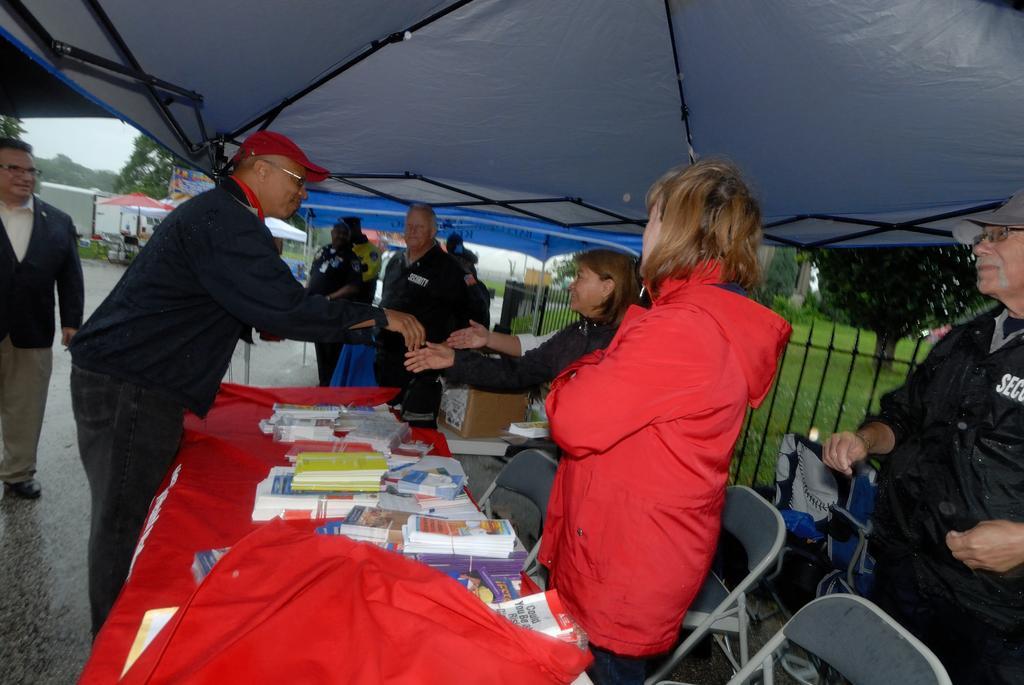Please provide a concise description of this image. In this image we can few persons standing under a roof. There are groups of objects on a red surface and there are a few chairs. Behind the persons we can see fencing, grass, plants and trees. On the left side, we can see few tents, buildings, trees and the sky. 